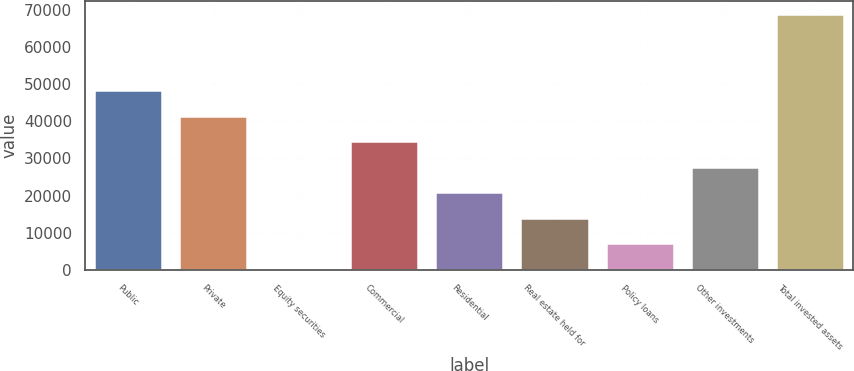Convert chart. <chart><loc_0><loc_0><loc_500><loc_500><bar_chart><fcel>Public<fcel>Private<fcel>Equity securities<fcel>Commercial<fcel>Residential<fcel>Real estate held for<fcel>Policy loans<fcel>Other investments<fcel>Total invested assets<nl><fcel>48284.7<fcel>41442.5<fcel>389.3<fcel>34600.3<fcel>20915.9<fcel>14073.7<fcel>7231.5<fcel>27758.1<fcel>68811.3<nl></chart> 